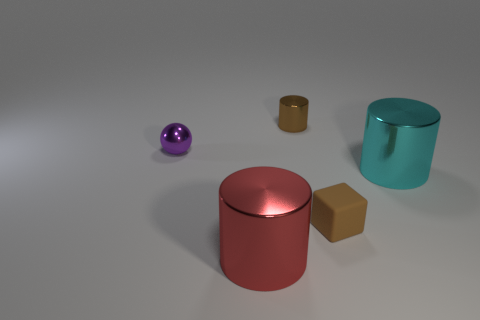Add 3 green rubber cylinders. How many objects exist? 8 Subtract all blocks. How many objects are left? 4 Add 2 big green cylinders. How many big green cylinders exist? 2 Subtract 0 yellow blocks. How many objects are left? 5 Subtract all large red rubber blocks. Subtract all tiny brown matte objects. How many objects are left? 4 Add 2 brown shiny cylinders. How many brown shiny cylinders are left? 3 